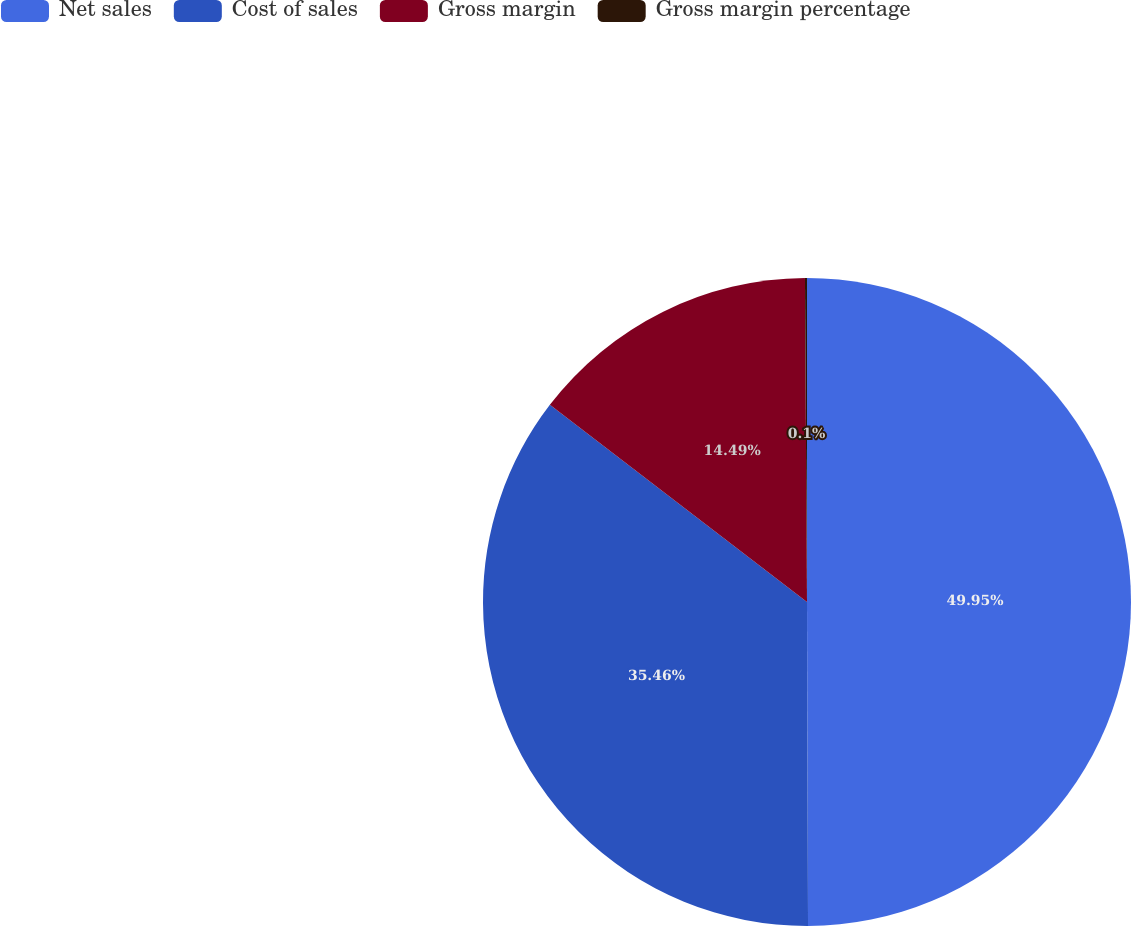<chart> <loc_0><loc_0><loc_500><loc_500><pie_chart><fcel>Net sales<fcel>Cost of sales<fcel>Gross margin<fcel>Gross margin percentage<nl><fcel>49.95%<fcel>35.46%<fcel>14.49%<fcel>0.1%<nl></chart> 